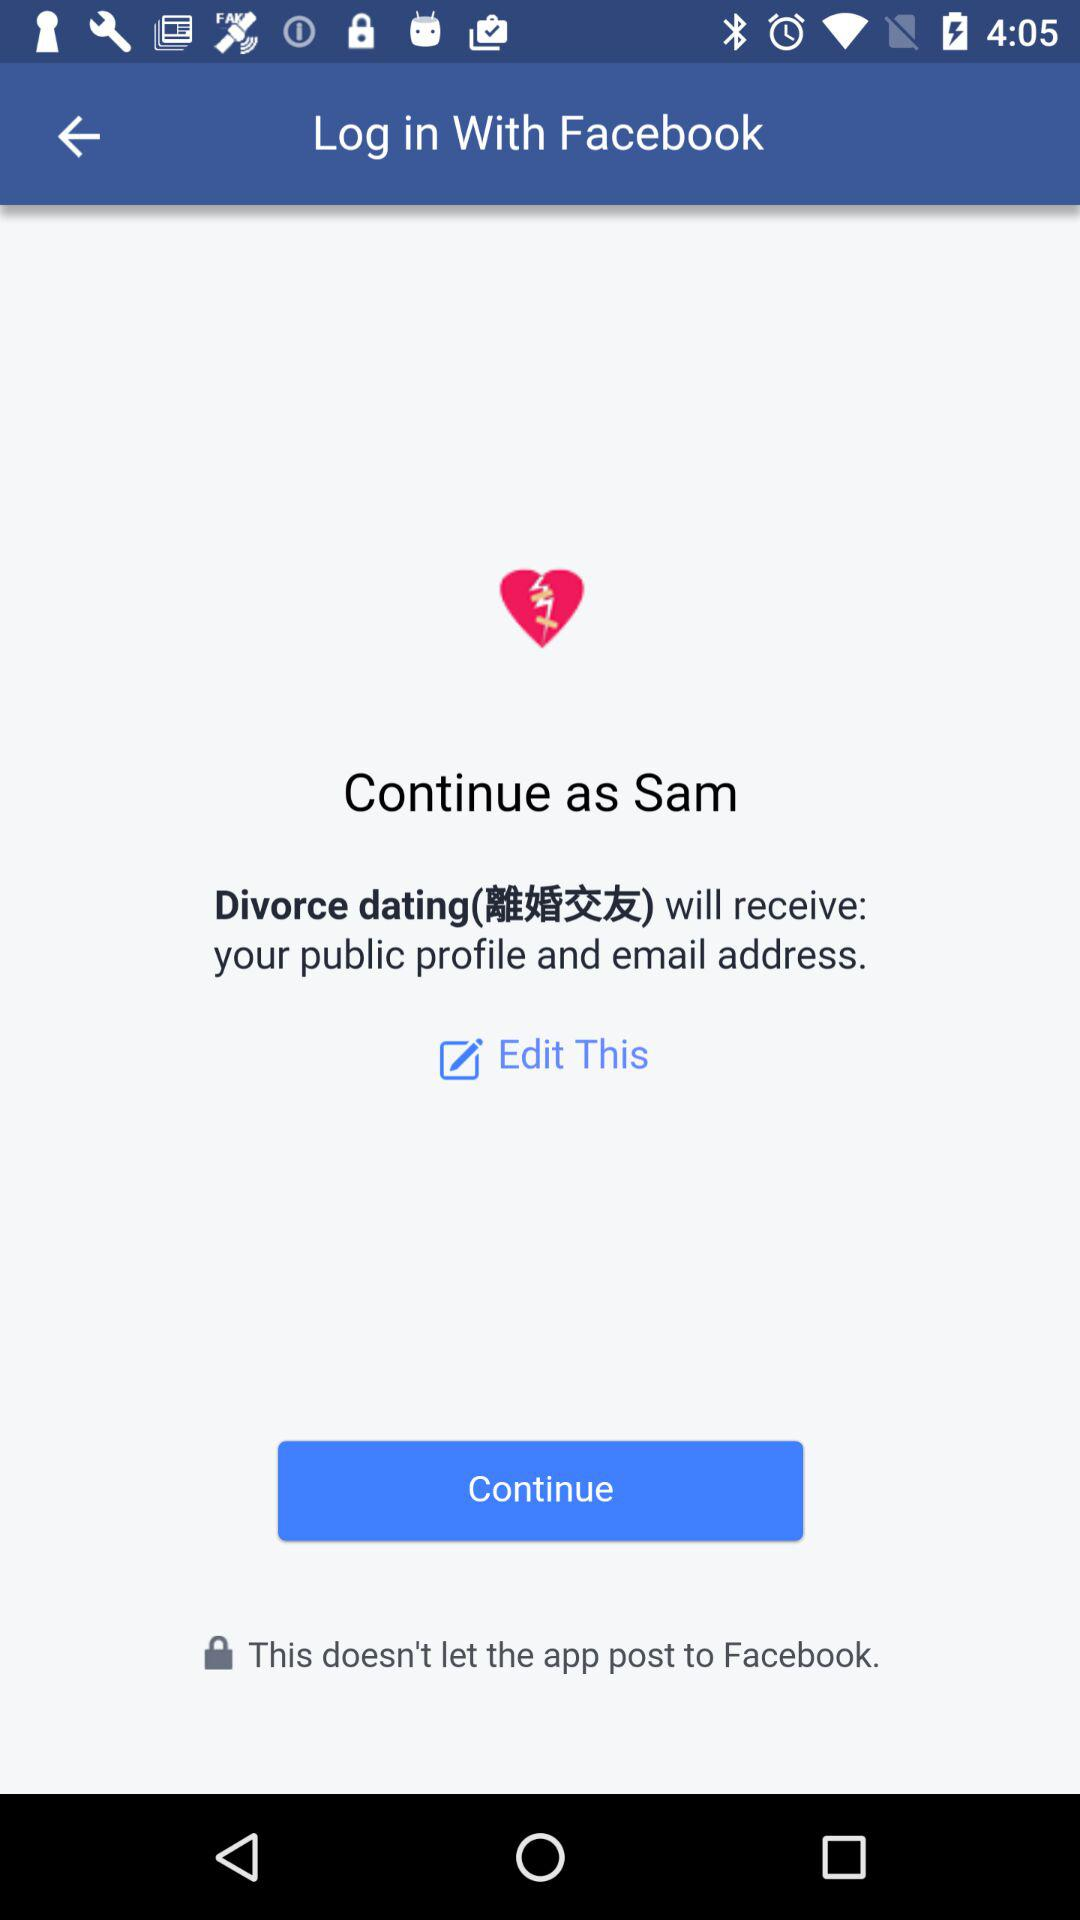What application is asking for permissions? The application that is asking for permission is "Divorce dating". 